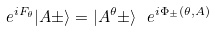Convert formula to latex. <formula><loc_0><loc_0><loc_500><loc_500>e ^ { i F _ { \theta } } | A \pm \rangle = | A ^ { \theta } \pm \rangle \ e ^ { i \Phi _ { \pm } ( \theta , A ) }</formula> 